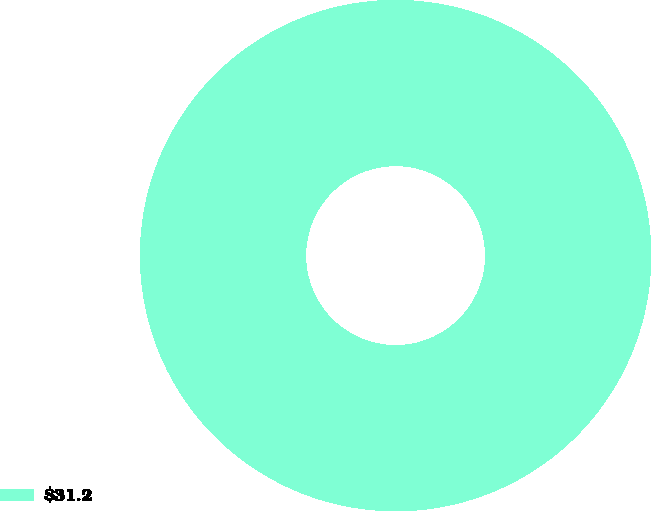<chart> <loc_0><loc_0><loc_500><loc_500><pie_chart><fcel>$31.2<nl><fcel>100.0%<nl></chart> 